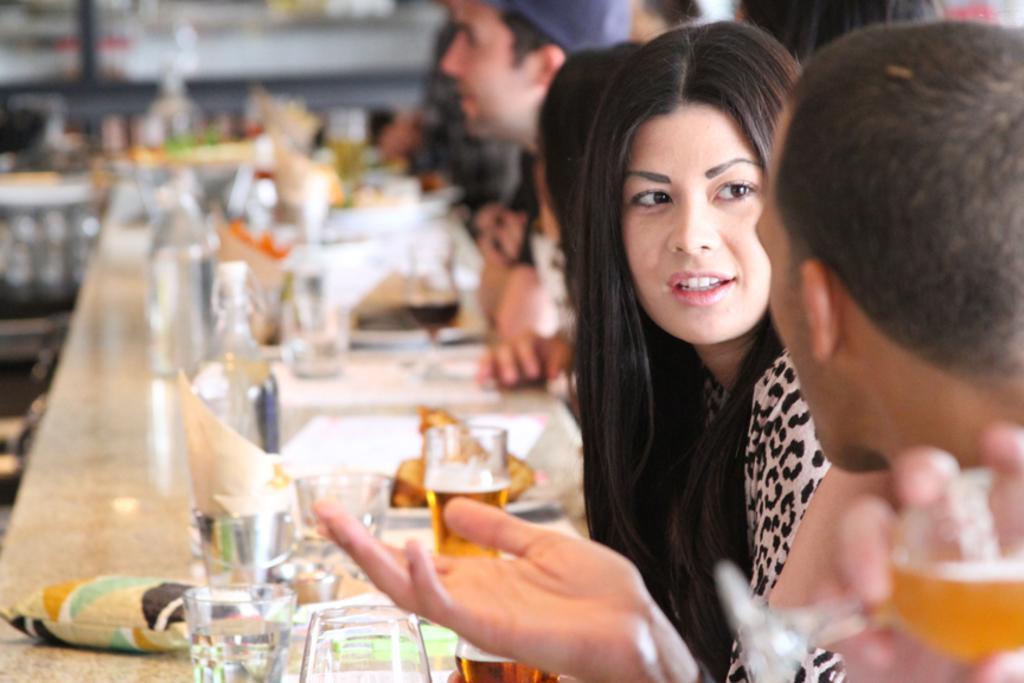How would you summarize this image in a sentence or two? In this picture we can see few persons sitting on chairs in front of a table and on the table we can see drinking glasses, plates and a food init. And the background is very blurry. 